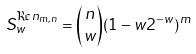<formula> <loc_0><loc_0><loc_500><loc_500>S _ { w } ^ { \Re n _ { m , n } } = { n \choose w } ( 1 - w 2 ^ { - w } ) ^ { m }</formula> 